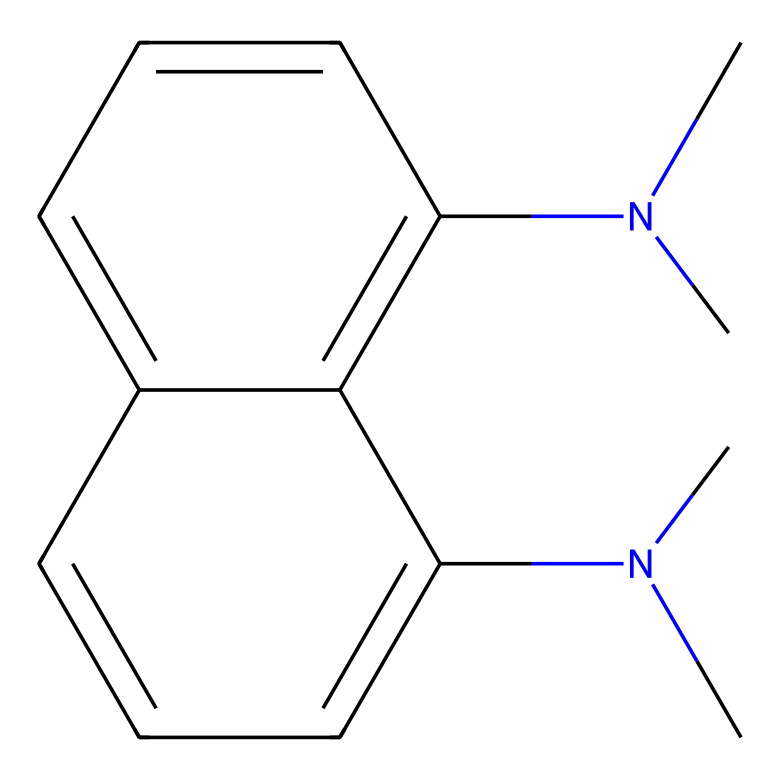what is the name of this chemical? The SMILES representation corresponds to a compound known as "1,8-diaminonaphthalene," which indicates a naphthalene ring structure with two amino groups due to the presence of nitrogen atoms in the formula.
Answer: 1,8-diaminonaphthalene how many nitrogen atoms are present in the structure? By analyzing the SMILES representation, we can identify two nitrogen atoms: one in each of the N(C) groups, confirming the presence of these atoms in the molecular structure.
Answer: 2 what type of molecular structure does this represent? The chemical shows a polycyclic structure based on naphthalene, which is characterized by multiple fused aromatic rings, providing insights into its stability and proton-accepting abilities.
Answer: polycyclic is this compound considered a superbase? Yes, the presence of the two nitrogen atoms and their ability to accept protons, making this compound highly basic, qualifies it as a superbase.
Answer: yes how many aromatic rings are present in this structure? The structure contains two fused aromatic rings forming a naphthalene structure, allowing us to conclude its aromatic nature based on the representation provided.
Answer: 2 what functional groups are present in this chemical? The main functional groups present are the amino groups, indicated by the N(C) terms, which are responsible for the basicity of the compound.
Answer: amino groups 